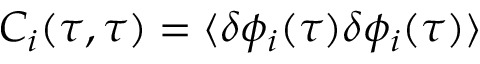Convert formula to latex. <formula><loc_0><loc_0><loc_500><loc_500>C _ { i } ( \tau , \tau ) = \langle \delta \phi _ { i } ( \tau ) \delta \phi _ { i } ( \tau ) \rangle</formula> 